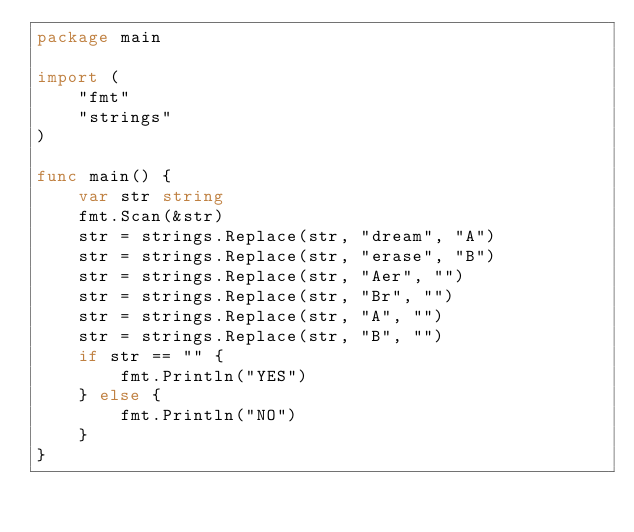<code> <loc_0><loc_0><loc_500><loc_500><_Go_>package main

import (
    "fmt"
    "strings"
)

func main() {
    var str string
    fmt.Scan(&str)
    str = strings.Replace(str, "dream", "A")
    str = strings.Replace(str, "erase", "B")
    str = strings.Replace(str, "Aer", "")
    str = strings.Replace(str, "Br", "")
    str = strings.Replace(str, "A", "")
    str = strings.Replace(str, "B", "")
    if str == "" {
        fmt.Println("YES")
    } else {
        fmt.Println("NO")
    }
}</code> 